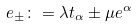Convert formula to latex. <formula><loc_0><loc_0><loc_500><loc_500>e _ { \pm } \colon = \lambda t _ { \alpha } \pm \mu e ^ { \alpha }</formula> 